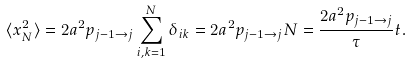Convert formula to latex. <formula><loc_0><loc_0><loc_500><loc_500>\langle x _ { N } ^ { 2 } \rangle = 2 a ^ { 2 } p _ { j - 1 \to j } \sum _ { i , k = 1 } ^ { N } \delta _ { i k } = 2 a ^ { 2 } p _ { j - 1 \to j } N = \frac { 2 a ^ { 2 } p _ { j - 1 \to j } } { \tau } t .</formula> 